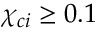<formula> <loc_0><loc_0><loc_500><loc_500>\chi _ { c i } \geq 0 . 1</formula> 